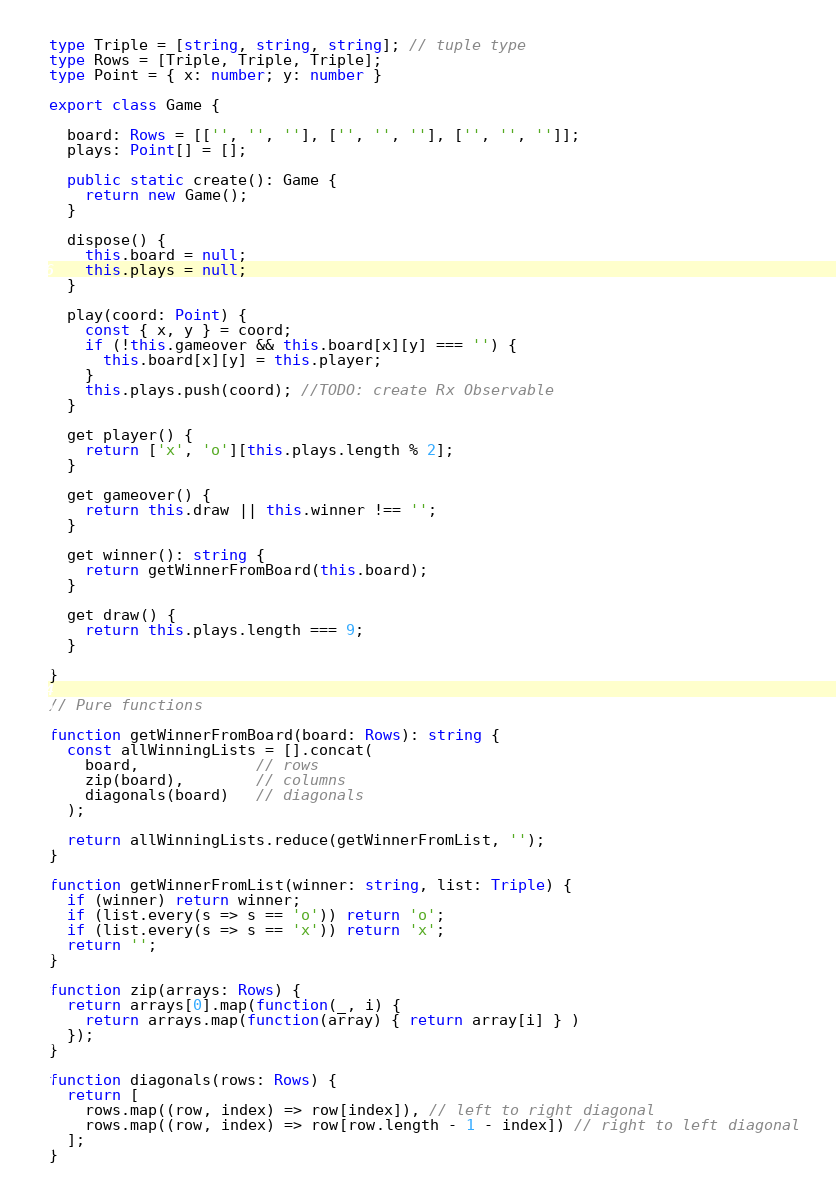Convert code to text. <code><loc_0><loc_0><loc_500><loc_500><_TypeScript_>type Triple = [string, string, string]; // tuple type
type Rows = [Triple, Triple, Triple];
type Point = { x: number; y: number }

export class Game {

  board: Rows = [['', '', ''], ['', '', ''], ['', '', '']];
  plays: Point[] = [];

  public static create(): Game {
    return new Game();
  }

  dispose() {
    this.board = null;
    this.plays = null;
  }

  play(coord: Point) {
    const { x, y } = coord;
    if (!this.gameover && this.board[x][y] === '') {
      this.board[x][y] = this.player;
    }
    this.plays.push(coord); //TODO: create Rx Observable
  }

  get player() {
    return ['x', 'o'][this.plays.length % 2];
  }

  get gameover() {
    return this.draw || this.winner !== '';
  }

  get winner(): string {
    return getWinnerFromBoard(this.board);
  }

  get draw() {
    return this.plays.length === 9;
  }

}

// Pure functions

function getWinnerFromBoard(board: Rows): string {
  const allWinningLists = [].concat(
    board,             // rows
    zip(board),        // columns
    diagonals(board)   // diagonals
  );

  return allWinningLists.reduce(getWinnerFromList, '');
}

function getWinnerFromList(winner: string, list: Triple) {
  if (winner) return winner;
  if (list.every(s => s == 'o')) return 'o';
  if (list.every(s => s == 'x')) return 'x';
  return '';
}

function zip(arrays: Rows) {
  return arrays[0].map(function(_, i) {
    return arrays.map(function(array) { return array[i] } )
  });
}

function diagonals(rows: Rows) {
  return [
    rows.map((row, index) => row[index]), // left to right diagonal
    rows.map((row, index) => row[row.length - 1 - index]) // right to left diagonal
  ];
}
</code> 